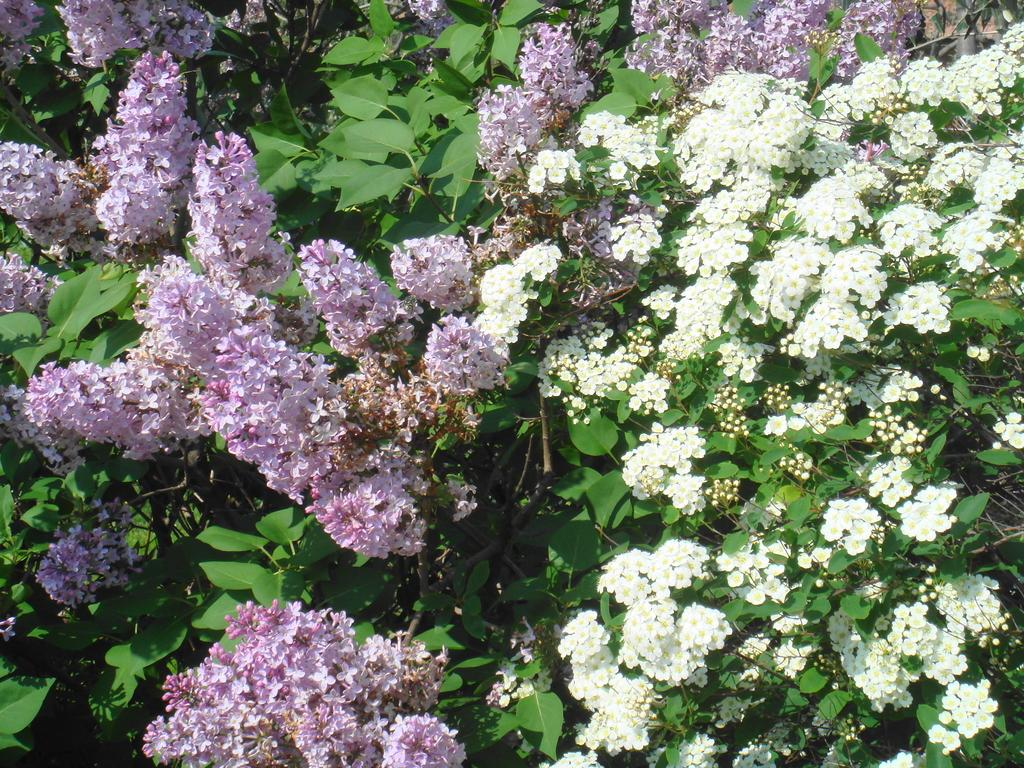What type of vegetation can be seen in the image? There are trees in the image. What features do the trees have? The trees have flowers, leaves, and branches. What colors are the flowers on the trees? The flowers are purple and white in color. Can you hear the voice of the ants crawling on the trees in the image? There are no ants present in the image, and therefore no voices can be heard. What type of board is used to support the trees in the image? There is no board present in the image; the trees are standing on their own. 